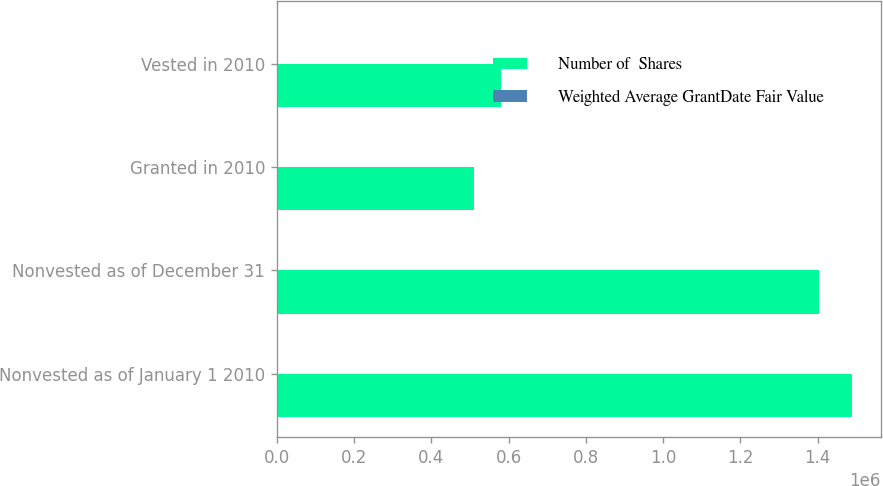<chart> <loc_0><loc_0><loc_500><loc_500><stacked_bar_chart><ecel><fcel>Nonvested as of January 1 2010<fcel>Nonvested as of December 31<fcel>Granted in 2010<fcel>Vested in 2010<nl><fcel>Number of  Shares<fcel>1.48919e+06<fcel>1.40211e+06<fcel>511418<fcel>579736<nl><fcel>Weighted Average GrantDate Fair Value<fcel>54.81<fcel>48.4<fcel>37.13<fcel>38.83<nl></chart> 